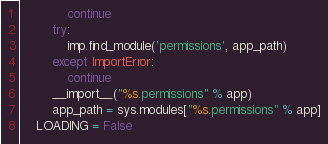Convert code to text. <code><loc_0><loc_0><loc_500><loc_500><_Python_>            continue
        try:
            imp.find_module('permissions', app_path)
        except ImportError:
            continue
        __import__("%s.permissions" % app)
        app_path = sys.modules["%s.permissions" % app]
    LOADING = False
</code> 